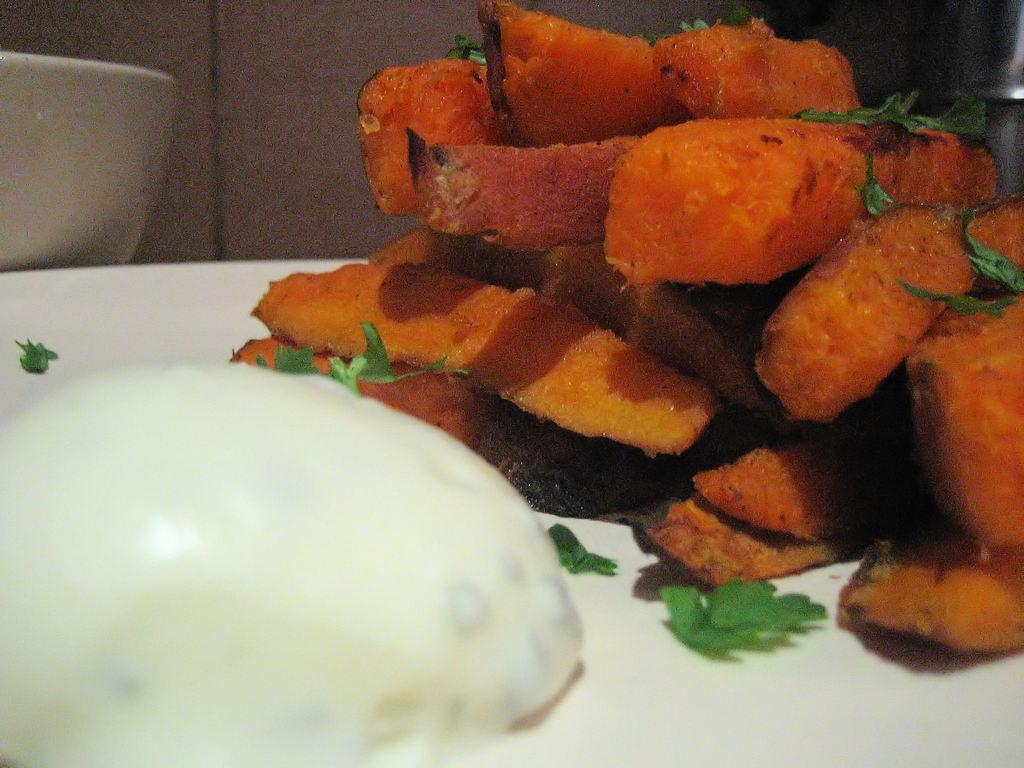How would you summarize this image in a sentence or two? In this image, I can see french fries with chopped coriander leaves and other food item on the plate. This looks like a bowl. 